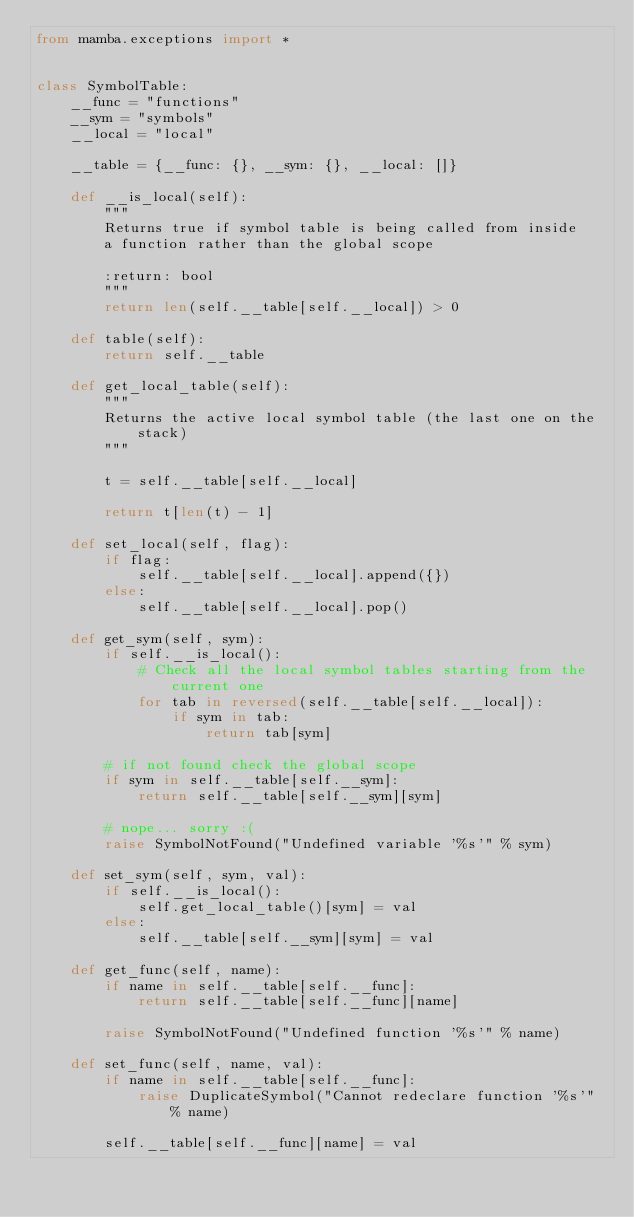<code> <loc_0><loc_0><loc_500><loc_500><_Python_>from mamba.exceptions import *


class SymbolTable:
    __func = "functions"
    __sym = "symbols"
    __local = "local"

    __table = {__func: {}, __sym: {}, __local: []}

    def __is_local(self):
        """
        Returns true if symbol table is being called from inside
        a function rather than the global scope

        :return: bool
        """
        return len(self.__table[self.__local]) > 0

    def table(self):
        return self.__table

    def get_local_table(self):
        """
        Returns the active local symbol table (the last one on the stack)
        """

        t = self.__table[self.__local]

        return t[len(t) - 1]

    def set_local(self, flag):
        if flag:
            self.__table[self.__local].append({})
        else:
            self.__table[self.__local].pop()

    def get_sym(self, sym):
        if self.__is_local():
            # Check all the local symbol tables starting from the current one
            for tab in reversed(self.__table[self.__local]):
                if sym in tab:
                    return tab[sym]

        # if not found check the global scope
        if sym in self.__table[self.__sym]:
            return self.__table[self.__sym][sym]

        # nope... sorry :(
        raise SymbolNotFound("Undefined variable '%s'" % sym)

    def set_sym(self, sym, val):
        if self.__is_local():
            self.get_local_table()[sym] = val
        else:
            self.__table[self.__sym][sym] = val

    def get_func(self, name):
        if name in self.__table[self.__func]:
            return self.__table[self.__func][name]

        raise SymbolNotFound("Undefined function '%s'" % name)

    def set_func(self, name, val):
        if name in self.__table[self.__func]:
            raise DuplicateSymbol("Cannot redeclare function '%s'" % name)

        self.__table[self.__func][name] = val
</code> 